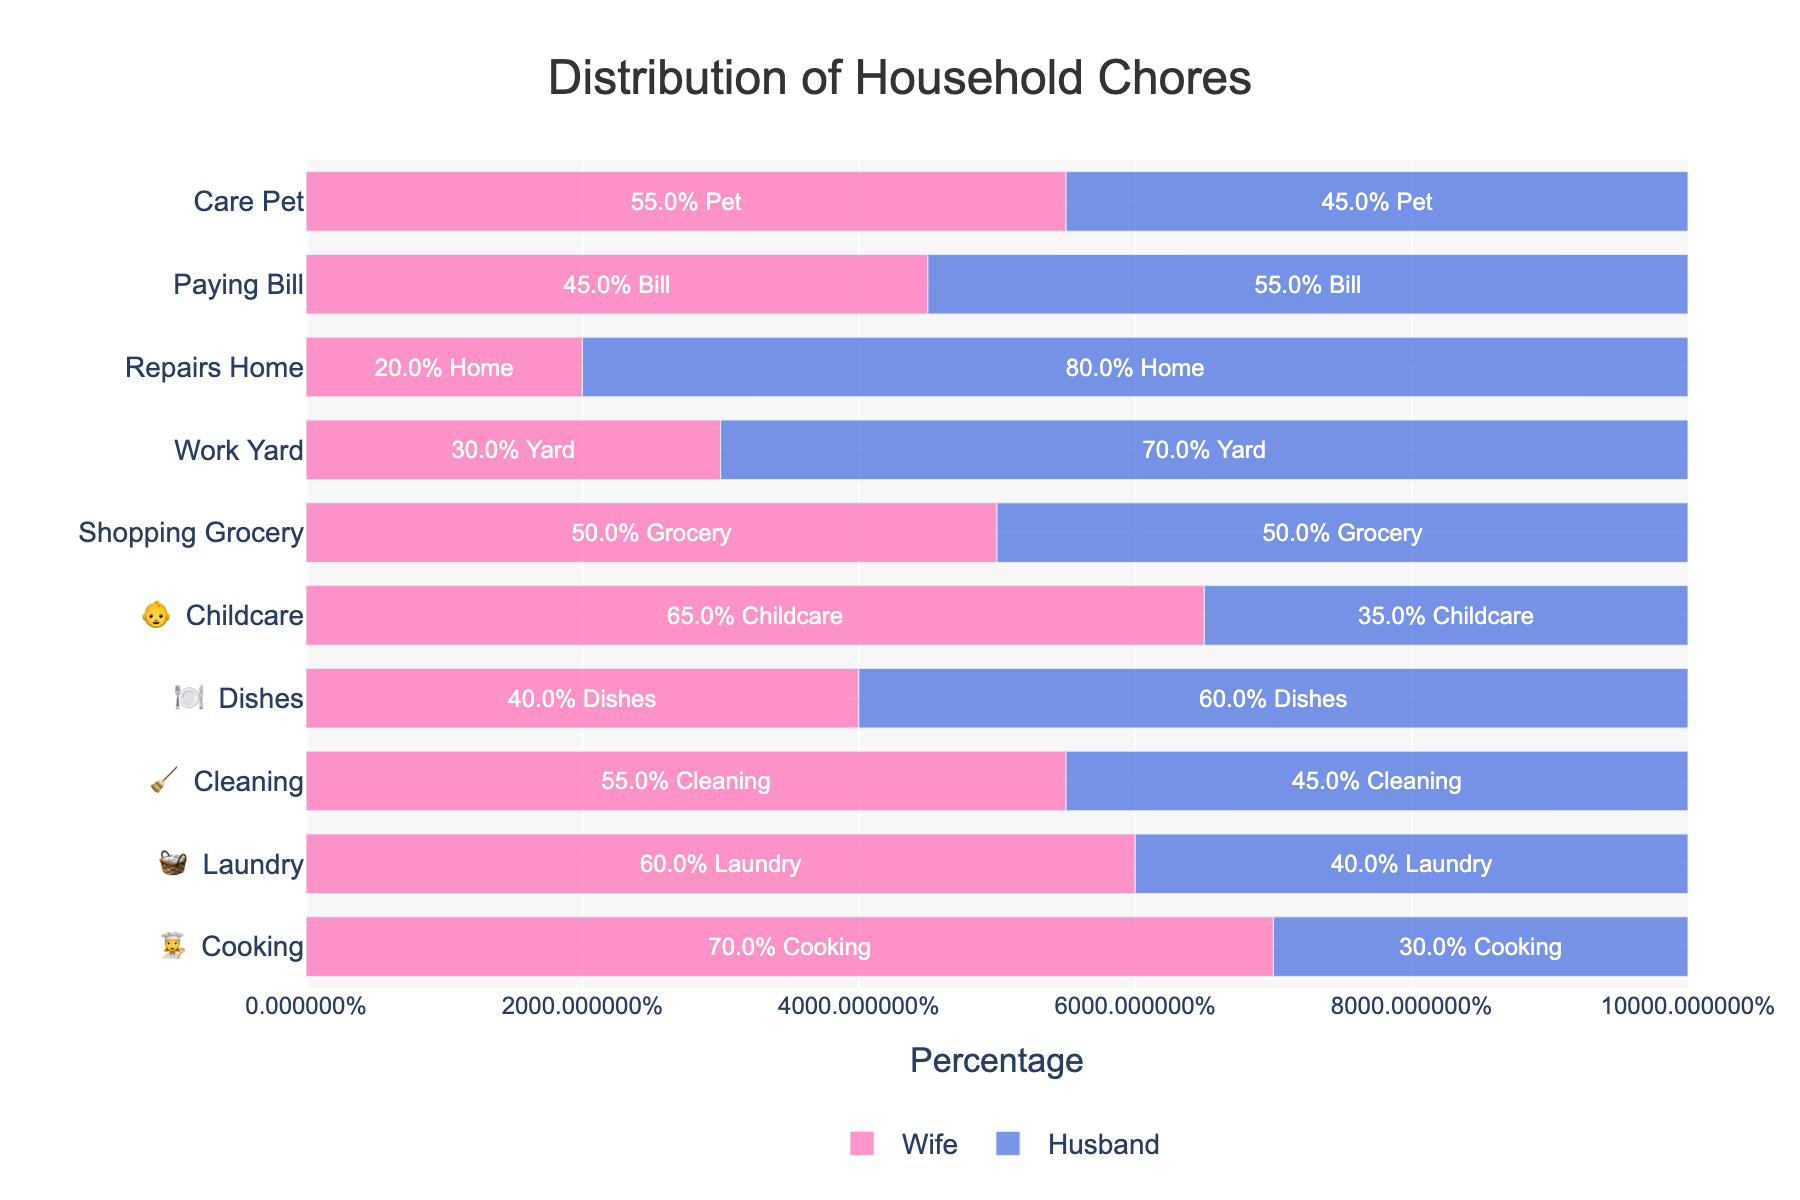What percentage of cooking is done by the wife? According to the figure, the wife does 70% of the cooking. This can be seen in the 'Cooking 👩‍🍳' bar where 70% is allocated to the wife.
Answer: 70% Who does a higher percentage of dishes, the wife or the husband? In the 'Dishes 🍽️' bar, the husband does 60% of the dishes, while the wife does 40%. Therefore, the husband does a higher percentage of the dishes.
Answer: The husband What is the task distribution of yard work between the wife and husband? The 'Yard Work 🌳' bar shows that 30% is done by the wife and 70% by the husband. This is observed directly from the corresponding percentages in the figure.
Answer: Wife: 30%, Husband: 70% Which tasks are shared equally between the wife and husband? 'Grocery Shopping 🛒' is split evenly with both the wife and husband doing 50%. This is seen in the 'Grocery Shopping 🛒' bar where both percentages are 50%.
Answer: Grocery Shopping 🛒 For which task does the wife do the least amount of work? 'Home Repairs 🔧' shows the wife does just 20%, which is the lowest percentage among all tasks for the wife. This can be noted by comparing all the percentages in the 'Wife' bars.
Answer: Home Repairs 🔧 Which task does the husband contribute the most to, and what is his percentage? The husband contributes most to 'Home Repairs 🔧' with 80%. This is evident in the 'Home Repairs 🔧' bar, which has the highest percentage for the husband.
Answer: Home Repairs 🔧, 80% How much more does the wife contribute to childcare compared to the husband? The wife contributes 65% to 'Childcare 👶', whereas the husband contributes 35%. To find the difference, subtract the husband's percentage from the wife's: 65% - 35% = 30%.
Answer: 30% What is the average percentage of chores done by the wife across all tasks? To calculate this, sum all the percentages associated with the wife and then divide by the number of tasks. (70% + 60% + 55% + 40% + 65% + 50% + 30% + 20% + 45% + 55%) / 10 = 49%.
Answer: 49% Which task has the most balanced distribution of work between partners? The most balanced distribution occurs in 'Grocery Shopping 🛒' where both partners share the work equally at 50%. This is noted by looking for the task where wife and husband's contributions are equal.
Answer: Grocery Shopping 🛒 In which tasks does the husband do at least 60% of the work, based on the visualizations? 'Dishes 🍽️' at 60%, 'Yard Work 🌳' at 70%, and 'Home Repairs 🔧' at 80% are the tasks where the husband does at least 60% of the work. This is deduced from identifying bars where the husband's percentage is greater than or equal to 60%.
Answer: Dishes 🍽️, Yard Work 🌳, Home Repairs 🔧 